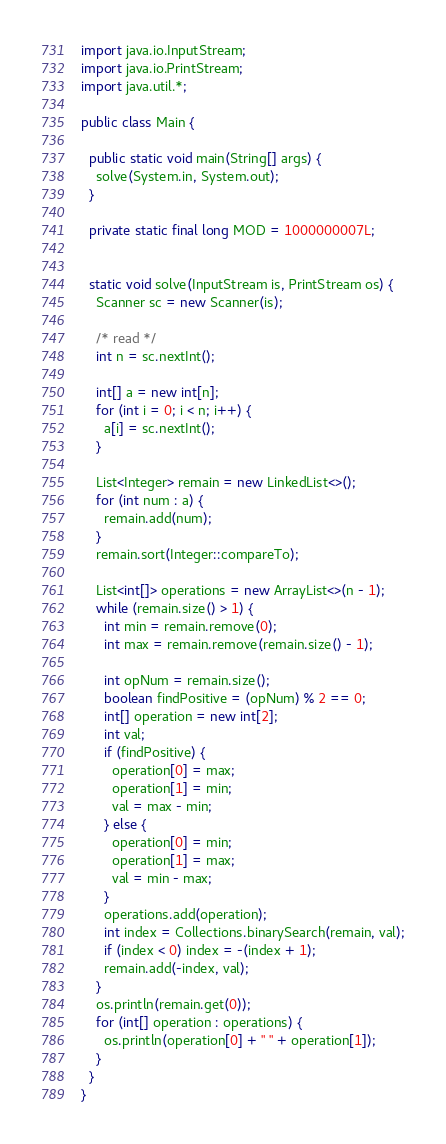<code> <loc_0><loc_0><loc_500><loc_500><_Java_>import java.io.InputStream;
import java.io.PrintStream;
import java.util.*;

public class Main {

  public static void main(String[] args) {
    solve(System.in, System.out);
  }

  private static final long MOD = 1000000007L;


  static void solve(InputStream is, PrintStream os) {
    Scanner sc = new Scanner(is);

    /* read */
    int n = sc.nextInt();

    int[] a = new int[n];
    for (int i = 0; i < n; i++) {
      a[i] = sc.nextInt();
    }

    List<Integer> remain = new LinkedList<>();
    for (int num : a) {
      remain.add(num);
    }
    remain.sort(Integer::compareTo);

    List<int[]> operations = new ArrayList<>(n - 1);
    while (remain.size() > 1) {
      int min = remain.remove(0);
      int max = remain.remove(remain.size() - 1);

      int opNum = remain.size();
      boolean findPositive = (opNum) % 2 == 0;
      int[] operation = new int[2];
      int val;
      if (findPositive) {
        operation[0] = max;
        operation[1] = min;
        val = max - min;
      } else {
        operation[0] = min;
        operation[1] = max;
        val = min - max;
      }
      operations.add(operation);
      int index = Collections.binarySearch(remain, val);
      if (index < 0) index = -(index + 1);
      remain.add(-index, val);
    }
    os.println(remain.get(0));
    for (int[] operation : operations) {
      os.println(operation[0] + " " + operation[1]);
    }
  }
}</code> 